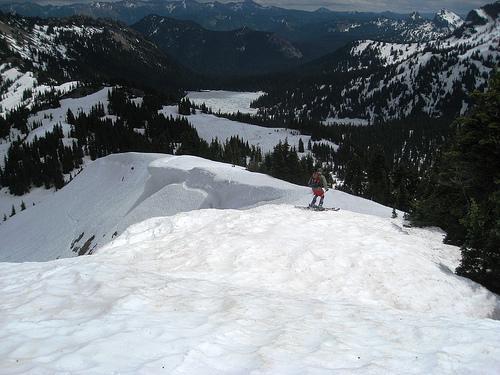How many skiers?
Give a very brief answer. 1. 